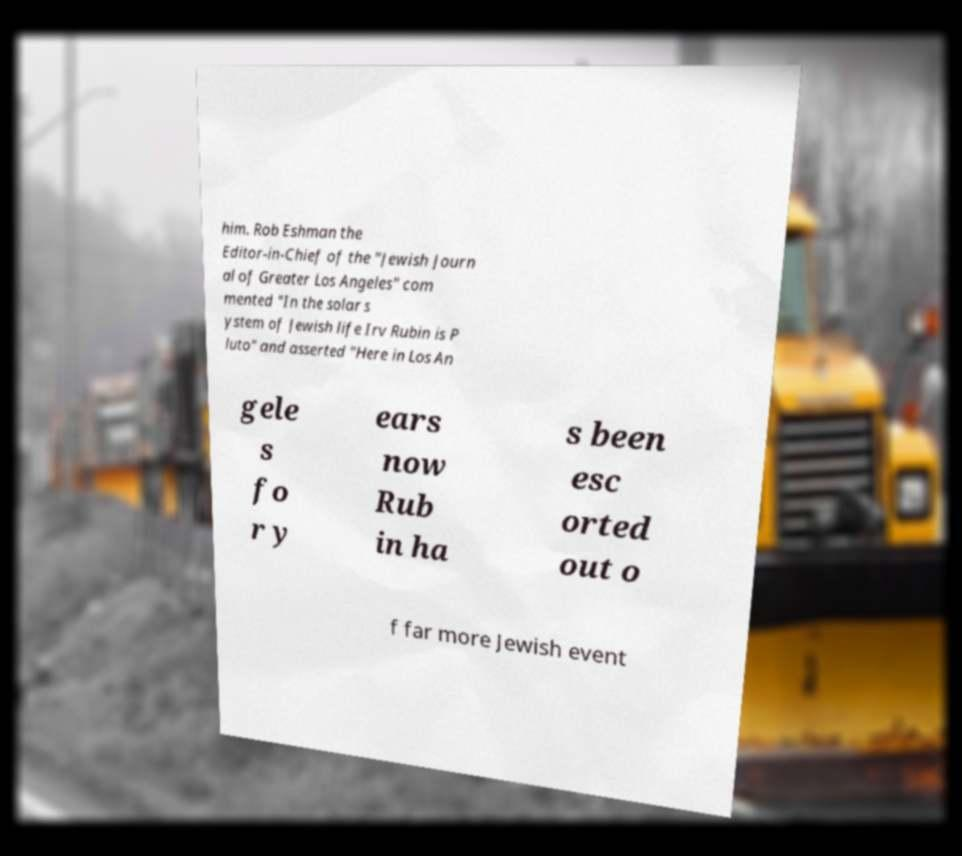I need the written content from this picture converted into text. Can you do that? him. Rob Eshman the Editor-in-Chief of the "Jewish Journ al of Greater Los Angeles" com mented "In the solar s ystem of Jewish life Irv Rubin is P luto" and asserted "Here in Los An gele s fo r y ears now Rub in ha s been esc orted out o f far more Jewish event 